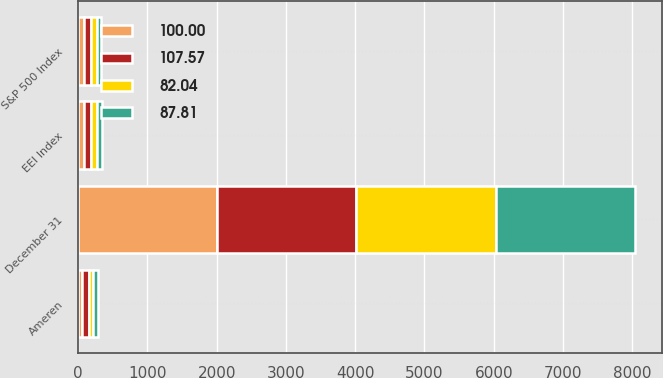Convert chart to OTSL. <chart><loc_0><loc_0><loc_500><loc_500><stacked_bar_chart><ecel><fcel>December 31<fcel>Ameren<fcel>S&P 500 Index<fcel>EEI Index<nl><fcel>107.57<fcel>2007<fcel>100<fcel>100<fcel>100<nl><fcel>87.81<fcel>2008<fcel>65.41<fcel>63<fcel>74.1<nl><fcel>100<fcel>2009<fcel>58.4<fcel>79.67<fcel>82.04<nl><fcel>82.04<fcel>2010<fcel>62.41<fcel>91.67<fcel>87.81<nl></chart> 